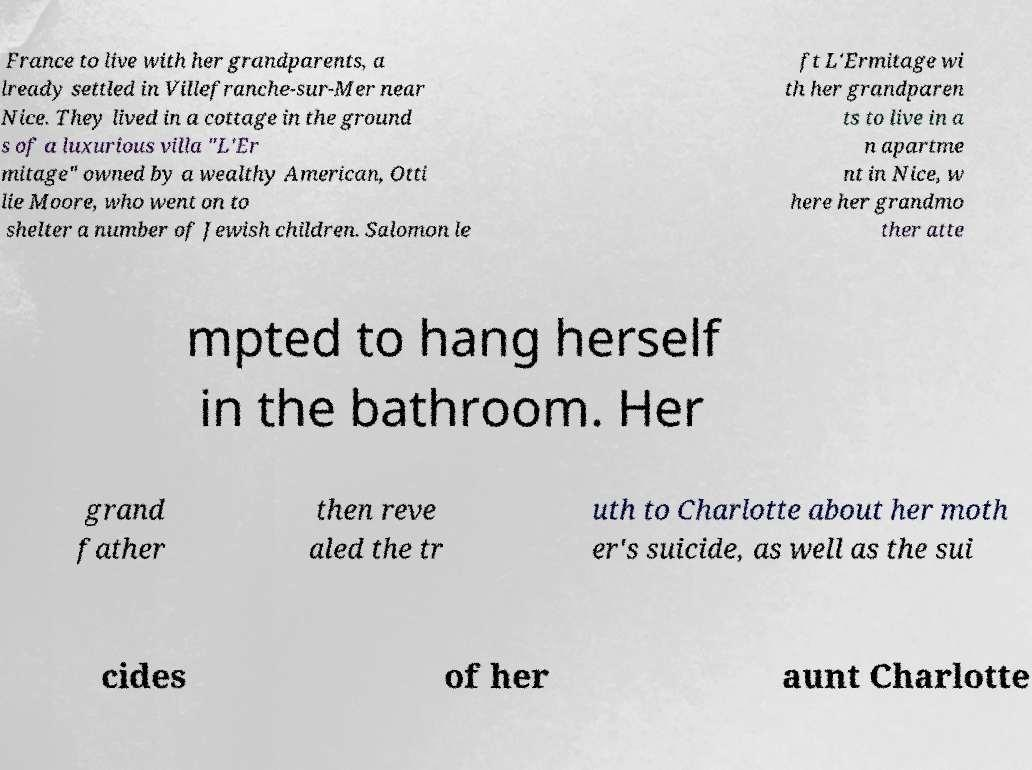There's text embedded in this image that I need extracted. Can you transcribe it verbatim? France to live with her grandparents, a lready settled in Villefranche-sur-Mer near Nice. They lived in a cottage in the ground s of a luxurious villa "L'Er mitage" owned by a wealthy American, Otti lie Moore, who went on to shelter a number of Jewish children. Salomon le ft L'Ermitage wi th her grandparen ts to live in a n apartme nt in Nice, w here her grandmo ther atte mpted to hang herself in the bathroom. Her grand father then reve aled the tr uth to Charlotte about her moth er's suicide, as well as the sui cides of her aunt Charlotte 